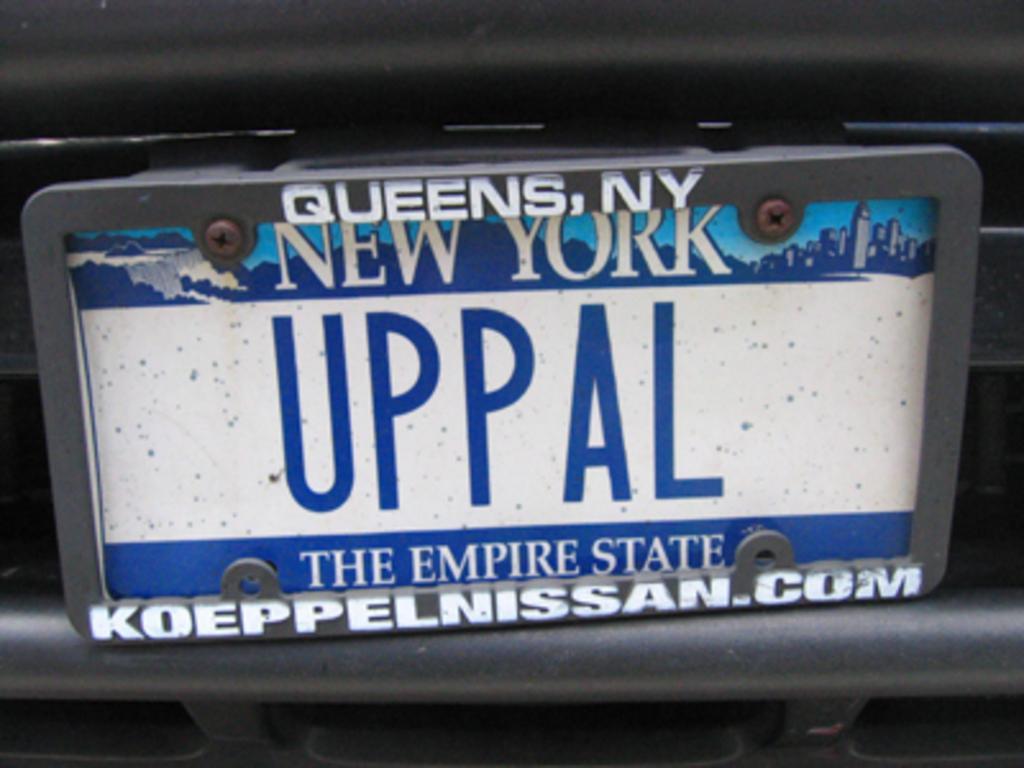Could you give a brief overview of what you see in this image? Here I can see a name board which is attached to a vehicle. On this board I can see some text in white and blue colors. 